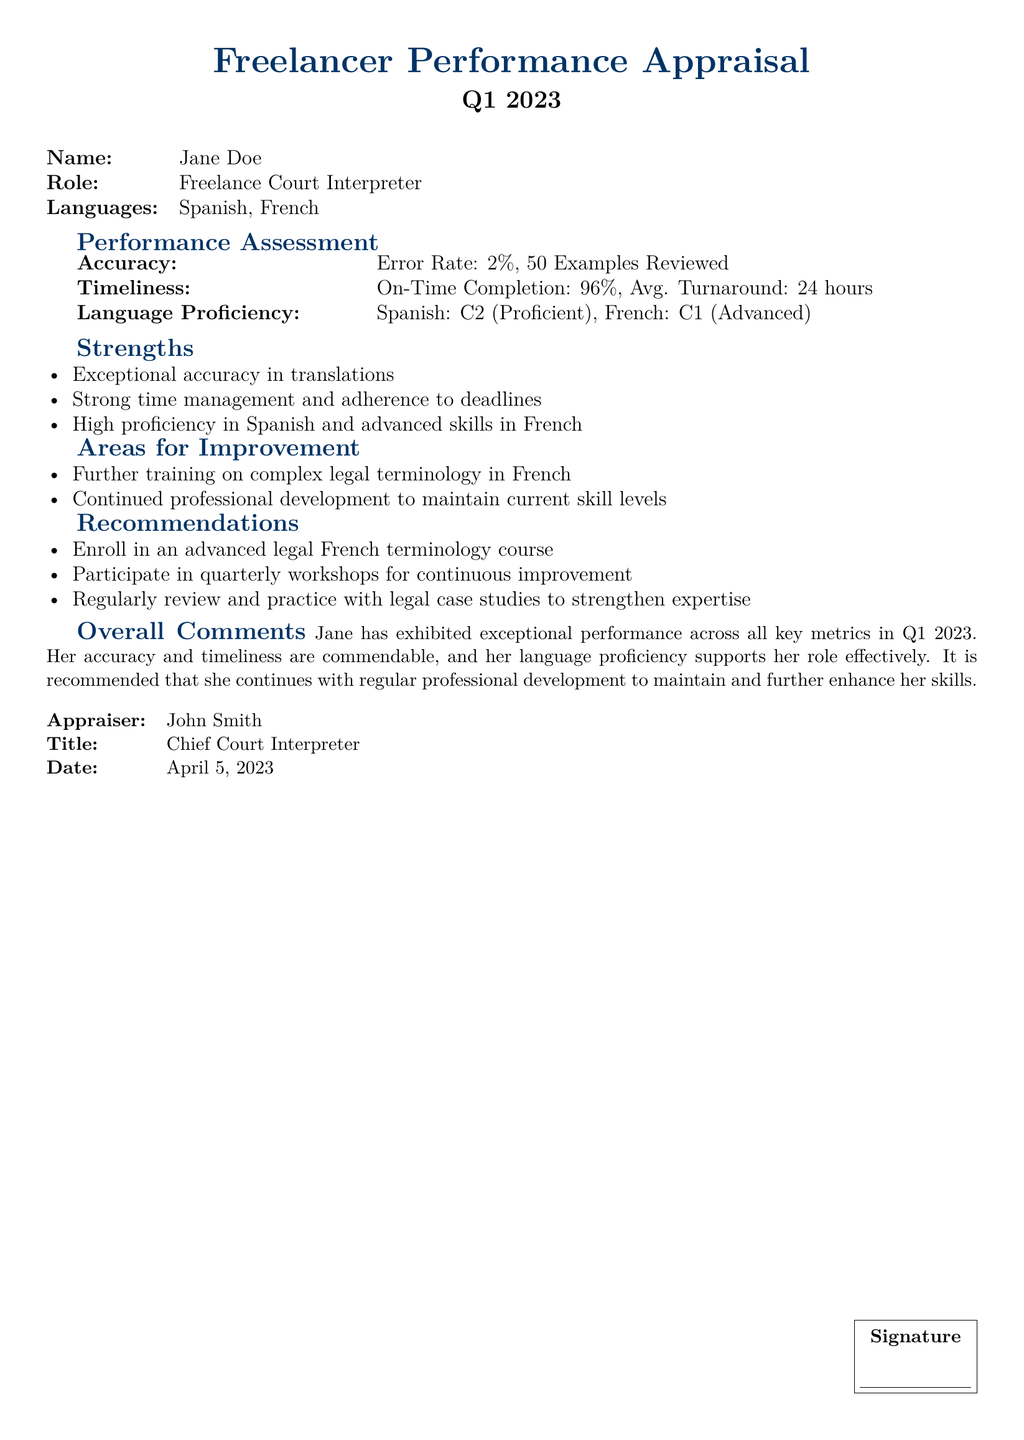What is the name of the freelancer? The name of the freelancer is stated at the beginning of the document in the personal information section.
Answer: Jane Doe What is the error rate of the freelancer? The error rate is mentioned under the accuracy section, which provides a specific error percentage related to the freelancer's performance.
Answer: 2% What is the average turnaround time for the freelancer's work? The average turnaround time can be found in the timeliness section, indicating how quickly the freelancer completes assignments on average.
Answer: 24 hours What language is designated as the freelancer's highest proficiency level? The language proficiency section outlines the freelancer's skills in different languages, specifying their highest level of proficiency.
Answer: Spanish What is one area for improvement noted in the appraisal? Areas for improvement are listed in a specific section that highlights any shortcomings or skills that could be developed further.
Answer: Complex legal terminology in French How many examples were reviewed to assess accuracy? This number is provided in the accuracy section and relates to the sample size used for evaluation purposes.
Answer: 50 What was the percentage of on-time completions? The timeliness section reveals the percentage of completed tasks that were submitted on time, reinforcing the freelancer's reliability.
Answer: 96% Which title does the appraiser hold? The title of the appraiser can be found towards the end of the document providing context about their role.
Answer: Chief Court Interpreter What recommendation is made for professional development? Recommendations are laid out in a dedicated section, suggesting ways the freelancer can improve or refine their skills.
Answer: Advanced legal French terminology course 